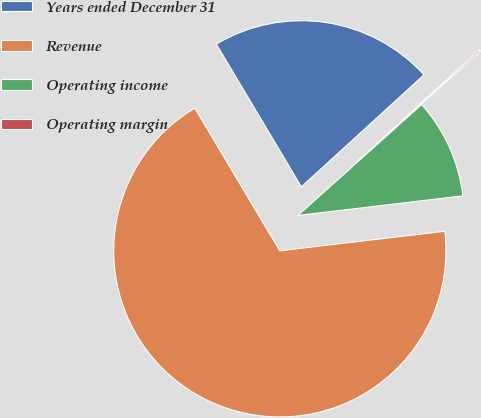Convert chart to OTSL. <chart><loc_0><loc_0><loc_500><loc_500><pie_chart><fcel>Years ended December 31<fcel>Revenue<fcel>Operating income<fcel>Operating margin<nl><fcel>21.77%<fcel>68.32%<fcel>9.75%<fcel>0.15%<nl></chart> 